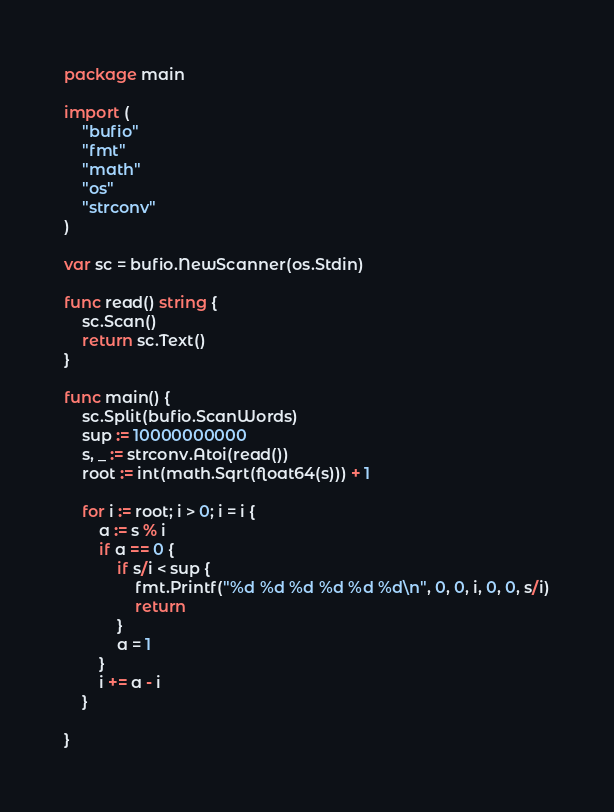Convert code to text. <code><loc_0><loc_0><loc_500><loc_500><_Go_>package main

import (
	"bufio"
	"fmt"
	"math"
	"os"
	"strconv"
)

var sc = bufio.NewScanner(os.Stdin)

func read() string {
	sc.Scan()
	return sc.Text()
}

func main() {
	sc.Split(bufio.ScanWords)
	sup := 10000000000
	s, _ := strconv.Atoi(read())
	root := int(math.Sqrt(float64(s))) + 1

	for i := root; i > 0; i = i {
		a := s % i
		if a == 0 {
			if s/i < sup {
				fmt.Printf("%d %d %d %d %d %d\n", 0, 0, i, 0, 0, s/i)
				return
			}
			a = 1
		}
		i += a - i
	}

}
</code> 